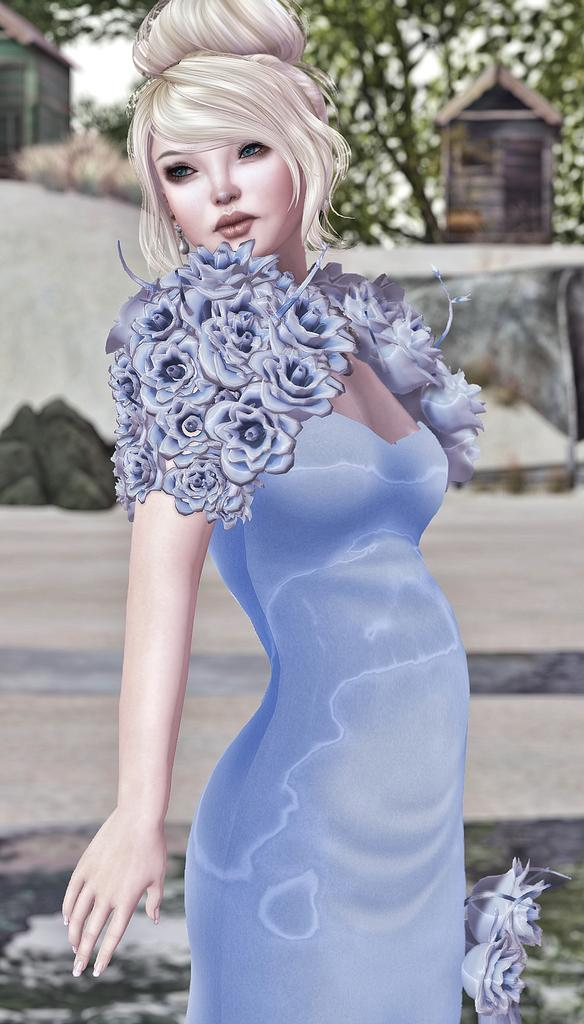What type of editing has been done to the image? The image is edited, but the specific type of editing is not mentioned in the facts. What is the main subject of the image? There is a depiction of a woman in the image. What can be seen in the background of the image? There is a path, a house, and trees in the background of the image. How many babies are crawling on the path in the image? There are no babies present in the image; it features a depiction of a woman and a background with a path, a house, and trees. What is the position of the sun in the image? The position of the sun is not mentioned in the facts, and there is no indication of the sun being present in the image. 